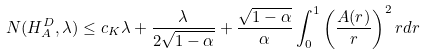Convert formula to latex. <formula><loc_0><loc_0><loc_500><loc_500>N ( H _ { A } ^ { D } , \lambda ) \leq c _ { K } \lambda + \frac { \lambda } { 2 \sqrt { 1 - \alpha } } + \frac { \sqrt { 1 - \alpha } } { \alpha } \int _ { 0 } ^ { 1 } \left ( \frac { A ( r ) } { r } \right ) ^ { 2 } r d r</formula> 